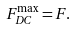Convert formula to latex. <formula><loc_0><loc_0><loc_500><loc_500>F _ { D C } ^ { \max } = F .</formula> 